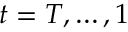Convert formula to latex. <formula><loc_0><loc_0><loc_500><loc_500>t = T , \dots , 1</formula> 